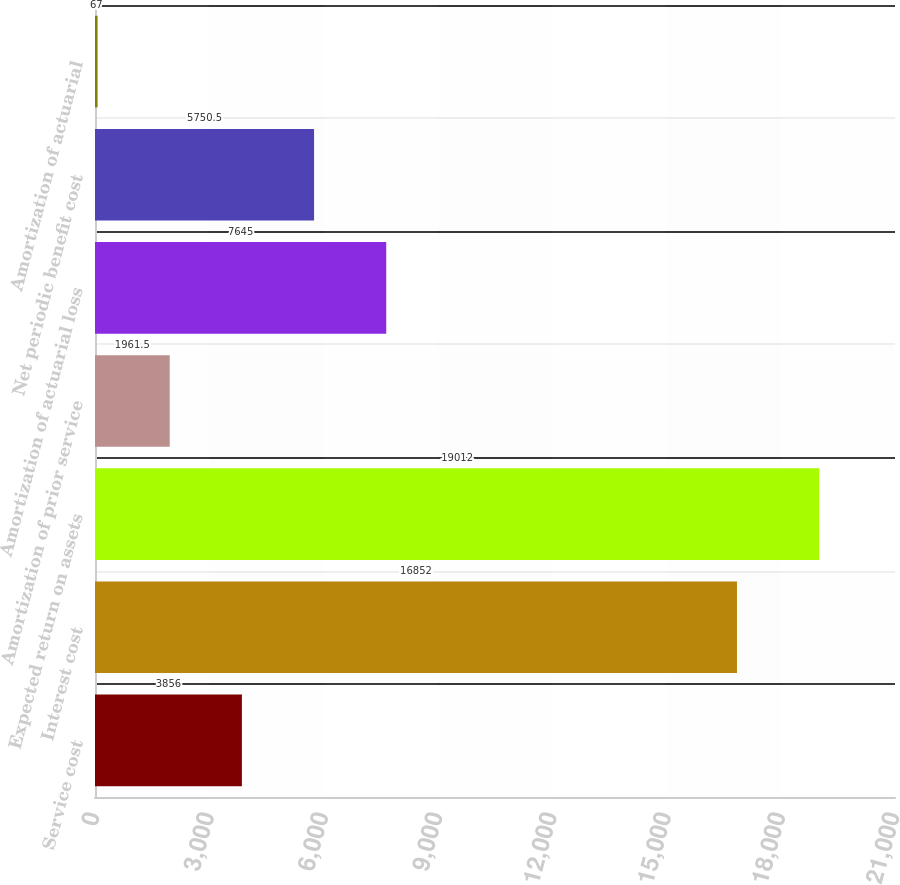<chart> <loc_0><loc_0><loc_500><loc_500><bar_chart><fcel>Service cost<fcel>Interest cost<fcel>Expected return on assets<fcel>Amortization of prior service<fcel>Amortization of actuarial loss<fcel>Net periodic benefit cost<fcel>Amortization of actuarial<nl><fcel>3856<fcel>16852<fcel>19012<fcel>1961.5<fcel>7645<fcel>5750.5<fcel>67<nl></chart> 